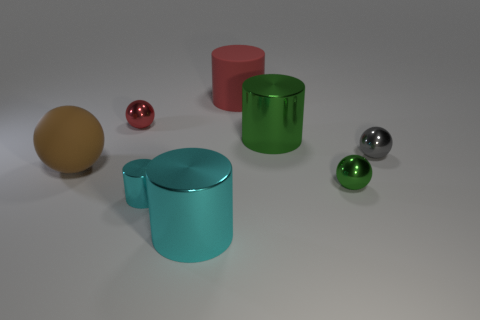How many cyan cylinders must be subtracted to get 1 cyan cylinders? 1 Add 2 large purple rubber cubes. How many objects exist? 10 Add 6 large green cylinders. How many large green cylinders are left? 7 Add 4 tiny cyan blocks. How many tiny cyan blocks exist? 4 Subtract 1 red balls. How many objects are left? 7 Subtract all small gray metallic things. Subtract all big cyan cylinders. How many objects are left? 6 